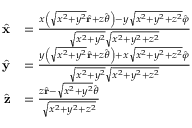<formula> <loc_0><loc_0><loc_500><loc_500>{ \begin{array} { r l } { { \hat { x } } } & { = { \frac { x \left ( { \sqrt { x ^ { 2 } + y ^ { 2 } } } { \hat { r } } + z { \hat { \theta } } \right ) - y { \sqrt { x ^ { 2 } + y ^ { 2 } + z ^ { 2 } } } { \hat { \varphi } } } { { \sqrt { x ^ { 2 } + y ^ { 2 } } } { \sqrt { x ^ { 2 } + y ^ { 2 } + z ^ { 2 } } } } } } \\ { { \hat { y } } } & { = { \frac { y \left ( { \sqrt { x ^ { 2 } + y ^ { 2 } } } { \hat { r } } + z { \hat { \theta } } \right ) + x { \sqrt { x ^ { 2 } + y ^ { 2 } + z ^ { 2 } } } { \hat { \varphi } } } { { \sqrt { x ^ { 2 } + y ^ { 2 } } } { \sqrt { x ^ { 2 } + y ^ { 2 } + z ^ { 2 } } } } } } \\ { { \hat { z } } } & { = { \frac { z { \hat { r } } - { \sqrt { x ^ { 2 } + y ^ { 2 } } } { \hat { \theta } } } { \sqrt { x ^ { 2 } + y ^ { 2 } + z ^ { 2 } } } } } \end{array} }</formula> 